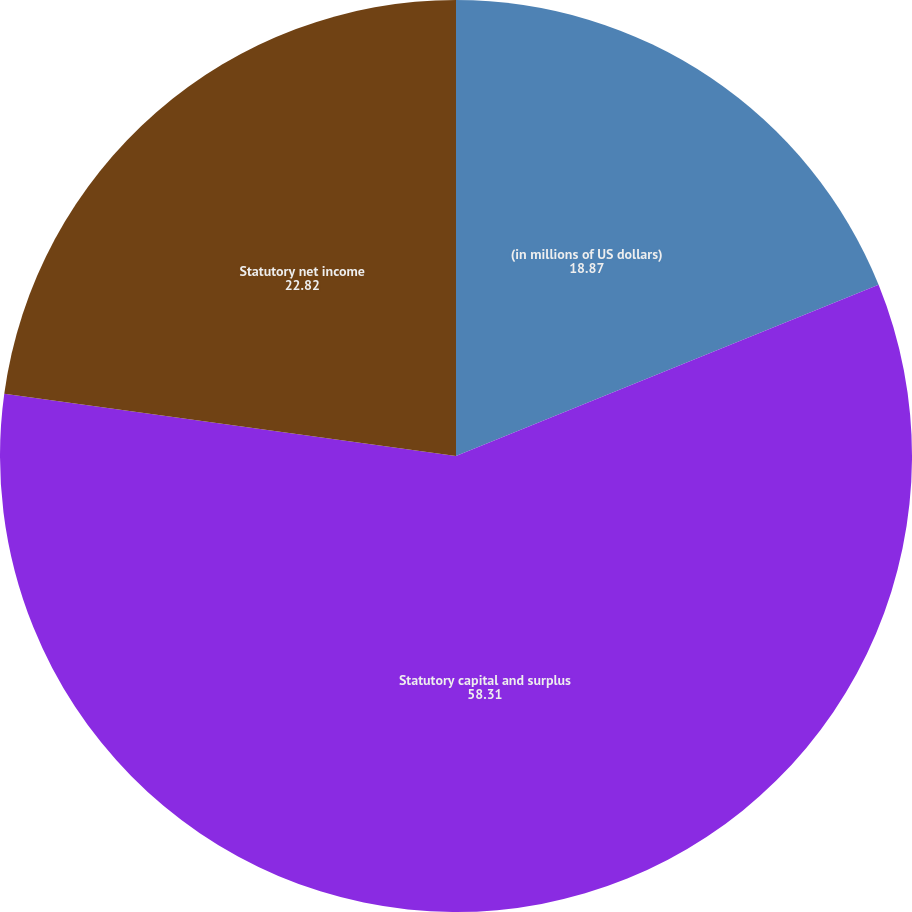Convert chart to OTSL. <chart><loc_0><loc_0><loc_500><loc_500><pie_chart><fcel>(in millions of US dollars)<fcel>Statutory capital and surplus<fcel>Statutory net income<nl><fcel>18.87%<fcel>58.31%<fcel>22.82%<nl></chart> 